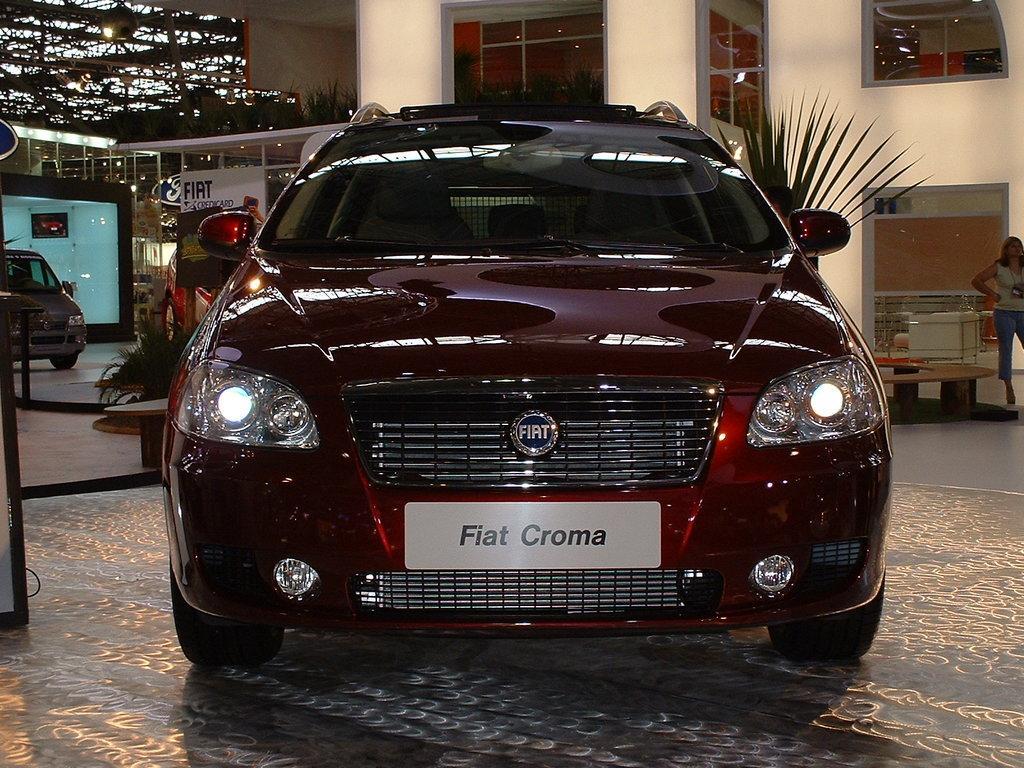Can you describe this image briefly? In this picture we can see a car. There is some text visible on this car. We can see a woman standing on the right side. There is another car visible on the left side. We can see a glass object and some things on the right side. We can see a few plants on the ground. There are a few plants on a white surface. We can see a few glass objects, lights and other things in the background. 